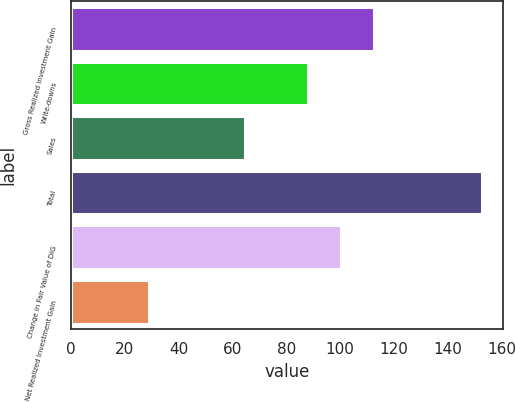Convert chart to OTSL. <chart><loc_0><loc_0><loc_500><loc_500><bar_chart><fcel>Gross Realized Investment Gain<fcel>Write-downs<fcel>Sales<fcel>Total<fcel>Change in Fair Value of DIG<fcel>Net Realized Investment Gain<nl><fcel>112.72<fcel>88<fcel>64.8<fcel>152.8<fcel>100.36<fcel>29.2<nl></chart> 